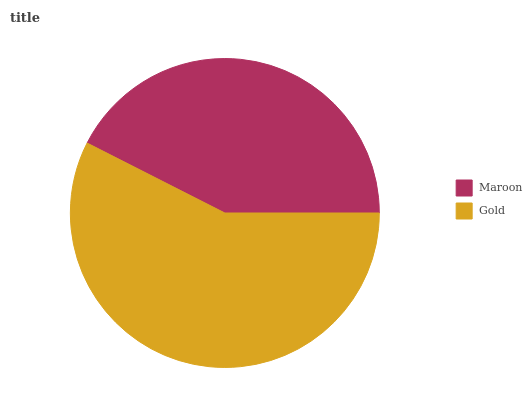Is Maroon the minimum?
Answer yes or no. Yes. Is Gold the maximum?
Answer yes or no. Yes. Is Gold the minimum?
Answer yes or no. No. Is Gold greater than Maroon?
Answer yes or no. Yes. Is Maroon less than Gold?
Answer yes or no. Yes. Is Maroon greater than Gold?
Answer yes or no. No. Is Gold less than Maroon?
Answer yes or no. No. Is Gold the high median?
Answer yes or no. Yes. Is Maroon the low median?
Answer yes or no. Yes. Is Maroon the high median?
Answer yes or no. No. Is Gold the low median?
Answer yes or no. No. 